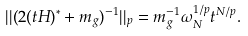Convert formula to latex. <formula><loc_0><loc_0><loc_500><loc_500>| | ( 2 ( t H ) ^ { * } + m _ { g } ) ^ { - 1 } | | _ { p } = m _ { g } ^ { - 1 } \omega _ { N } ^ { 1 / p } t ^ { N / p } .</formula> 